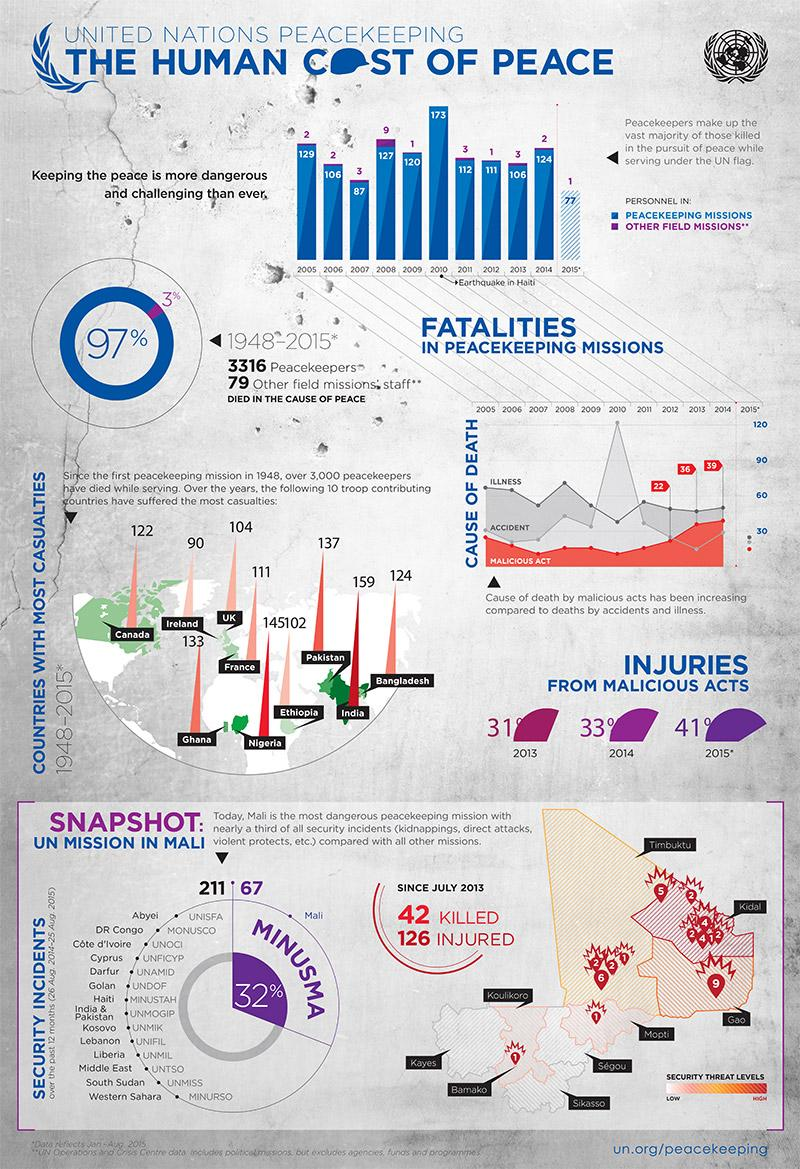Indicate a few pertinent items in this graphic. In the years between 2005 and 2015, the highest number of personnel were deployed in UN peacekeeping missions, with 2010 being the peak year. During the period of 1948-2015, approximately 3% of personnel were deployed in other field missions. In 2009, a total of 120 personnel were deployed in UN peacekeeping missions. A total of 97% of personnel were deployed in United Nations peacekeeping missions between 1948 and 2015. In 2008, the highest number of personnel were deployed in other field missions between 2005 and 2015. 